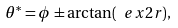<formula> <loc_0><loc_0><loc_500><loc_500>\theta ^ { * } = \phi \pm \arctan ( \ e x { 2 r } ) ,</formula> 